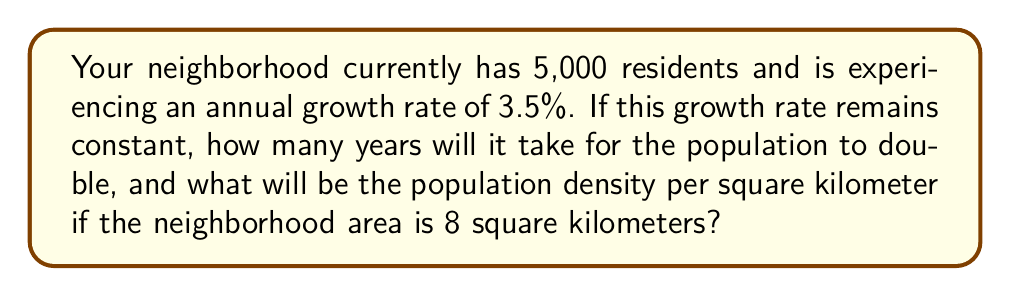Give your solution to this math problem. To solve this problem, we'll use the compound interest formula and the concept of doubling time:

1. Calculate the time for the population to double:
   The formula for doubling time is:
   $$ t = \frac{\ln(2)}{\ln(1 + r)} $$
   Where $t$ is time in years, and $r$ is the growth rate as a decimal.

   $$ t = \frac{\ln(2)}{\ln(1 + 0.035)} \approx 20.15 \text{ years} $$

2. Calculate the future population:
   Using the compound interest formula:
   $$ P = P_0 (1 + r)^t $$
   Where $P$ is the final population, $P_0$ is the initial population, $r$ is the growth rate, and $t$ is time in years.

   $$ P = 5000 (1 + 0.035)^{20.15} \approx 10,000 \text{ residents} $$

3. Calculate the population density:
   Density = Population / Area
   $$ \text{Density} = \frac{10,000 \text{ residents}}{8 \text{ km}^2} = 1,250 \text{ residents/km}^2 $$
Answer: 20.15 years; 1,250 residents/km² 